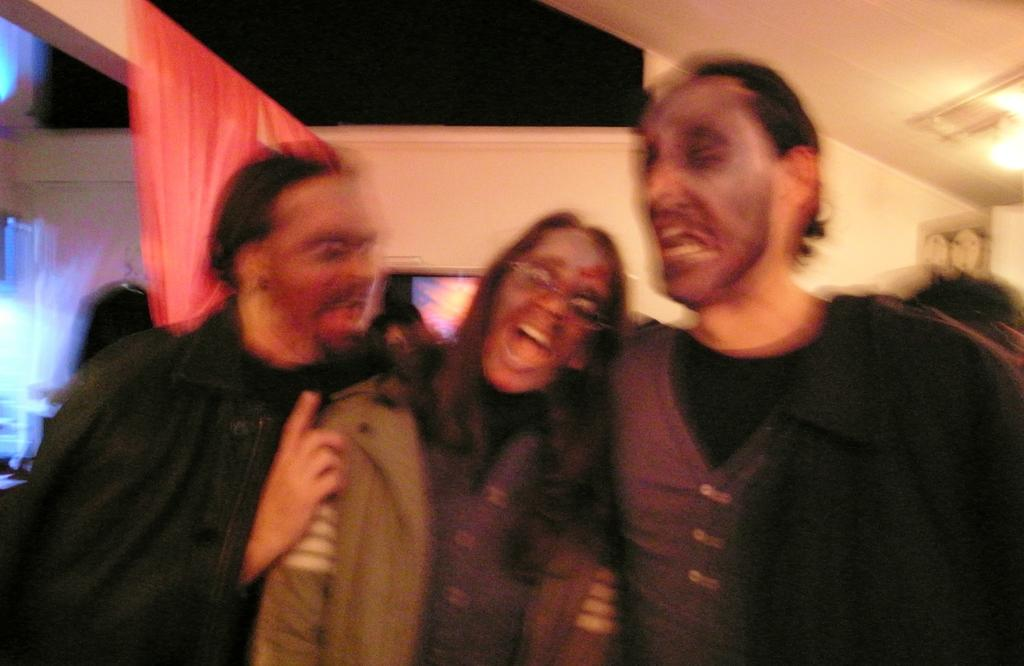What is happening in the image? There are persons standing in the image. Can you describe any objects or structures in the image? Yes, there is a cloth on a wooden plank on the left side of the image, and there is a light attached to the roof on the right side of the image. What type of nerve can be seen in the image? There is no nerve present in the image. How many errors can be found in the image? There are no errors in the image, as it accurately depicts the persons, cloth, wooden plank, and light. 